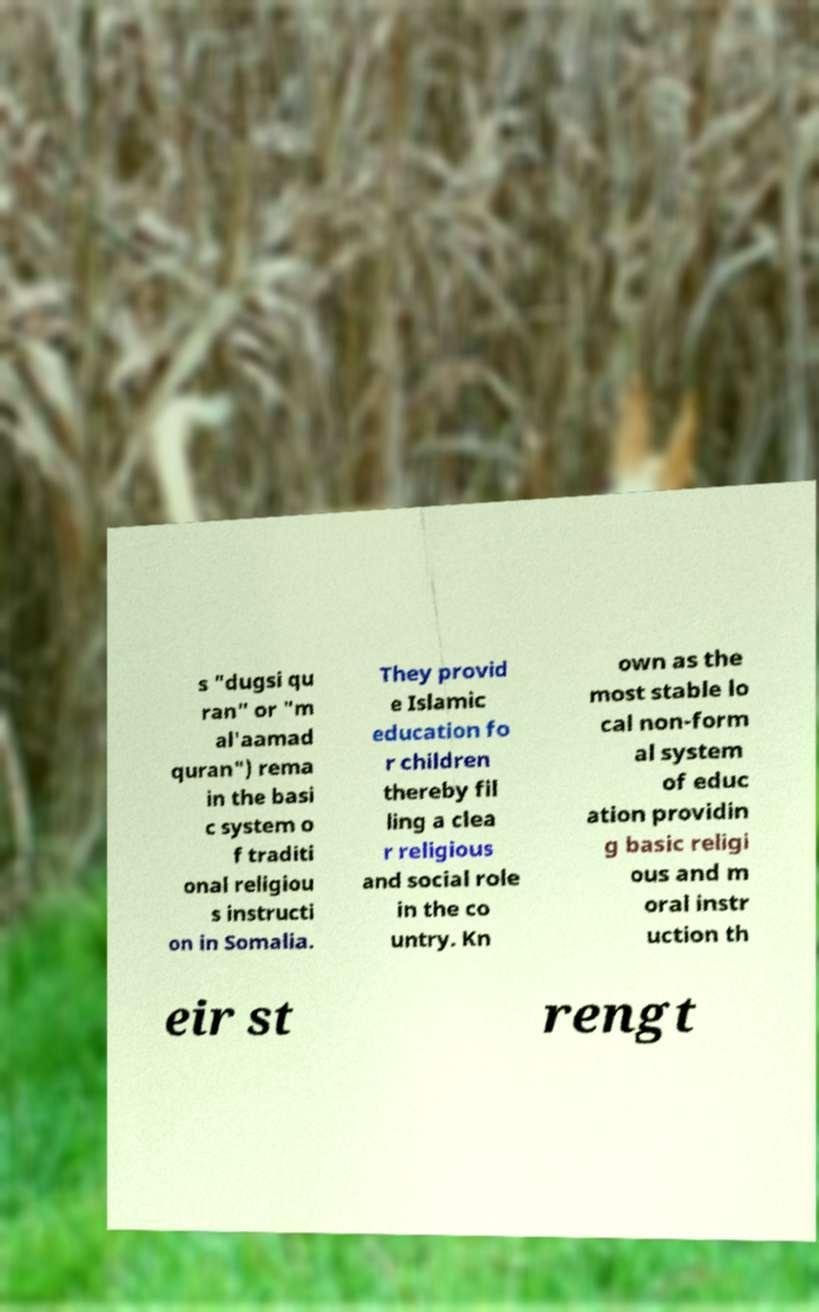Can you accurately transcribe the text from the provided image for me? s "dugsi qu ran" or "m al'aamad quran") rema in the basi c system o f traditi onal religiou s instructi on in Somalia. They provid e Islamic education fo r children thereby fil ling a clea r religious and social role in the co untry. Kn own as the most stable lo cal non-form al system of educ ation providin g basic religi ous and m oral instr uction th eir st rengt 